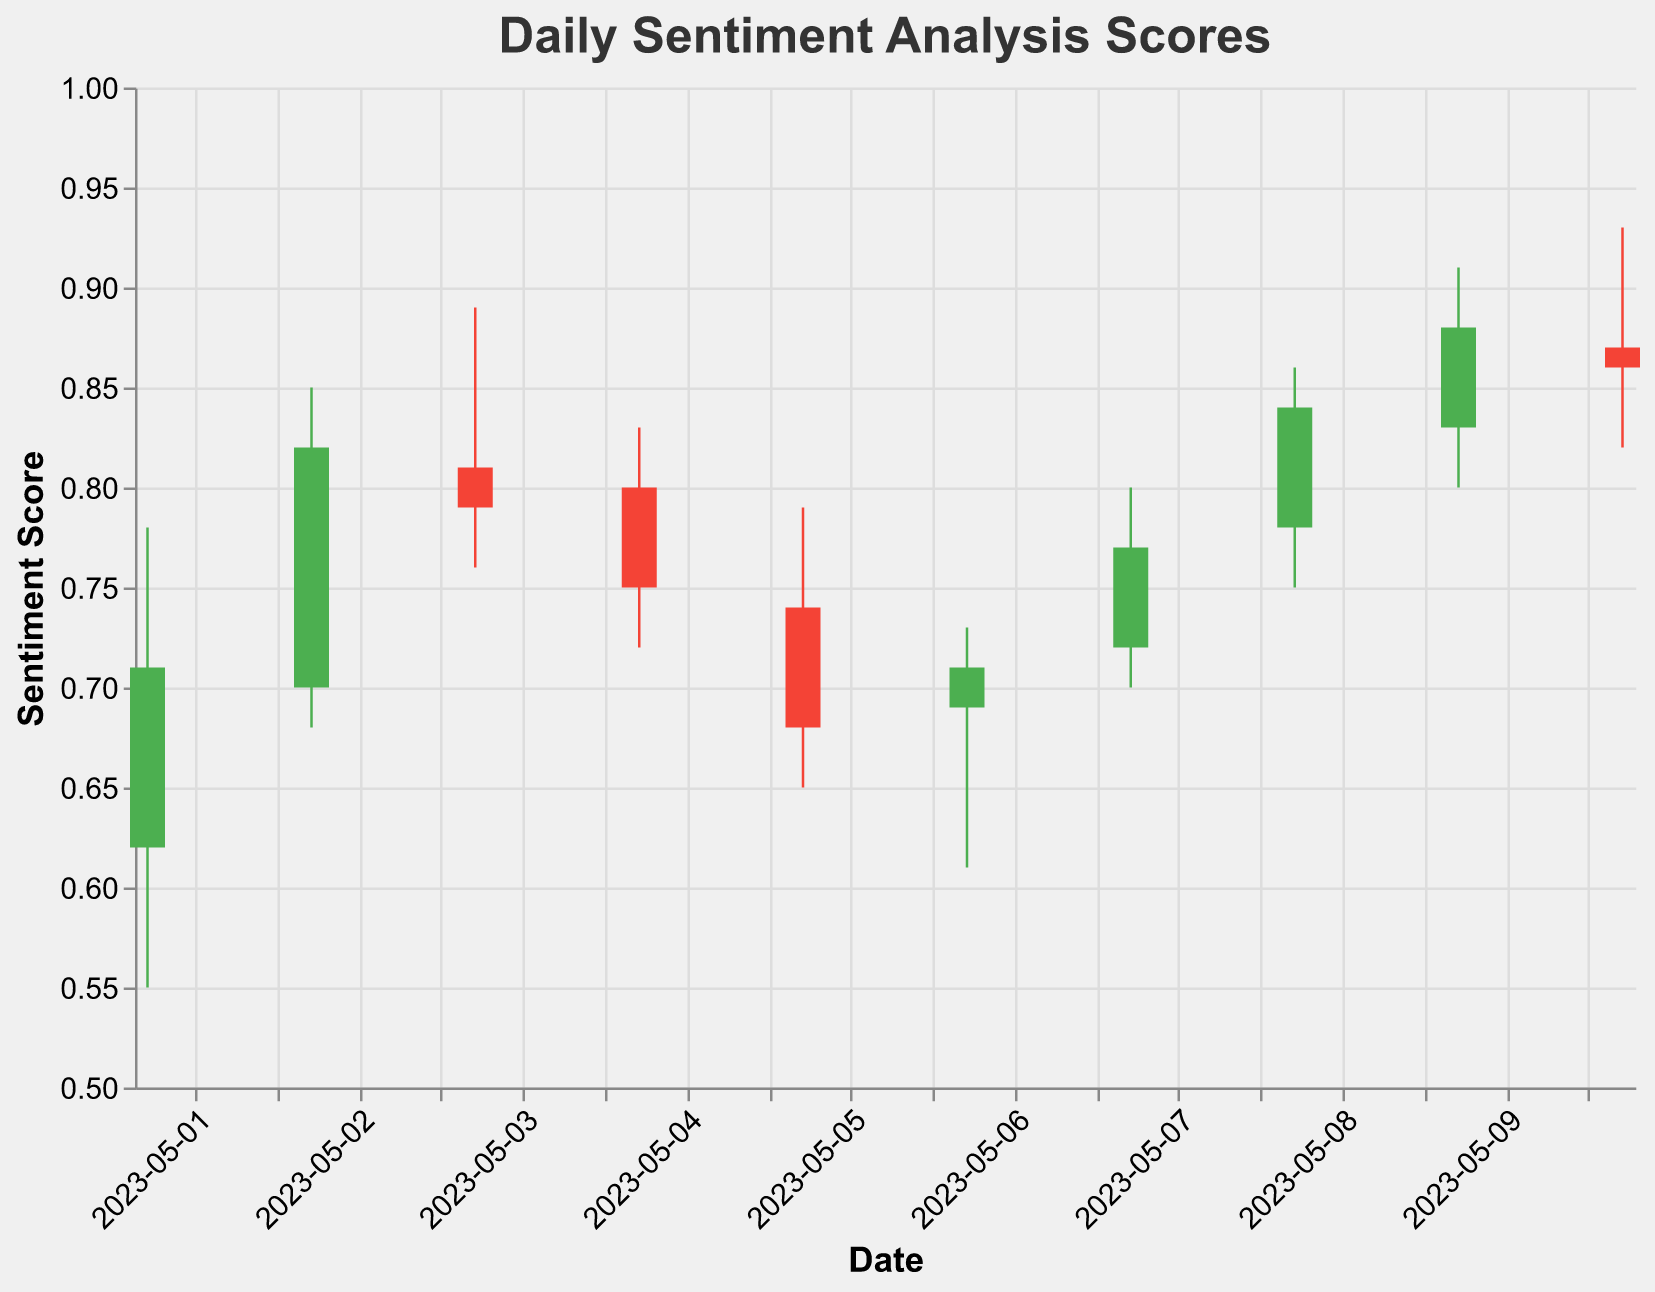What is the title of the chart? The title of the chart is typically displayed at the top of the figure. By reading it, we can determine the subject of the chart.
Answer: Daily Sentiment Analysis Scores What is the highest sentiment score recorded on May 10, 2023? Look at the row corresponding to May 10, 2023, and find the value under the "High" column.
Answer: 0.93 How many days show an increase in sentiment score from Open to Close? To determine this, we need to compare the "Open" and "Close" values for each day. A day shows an increase if the "Close" value is higher than the "Open" value.
Answer: 7 days On which date did the sentiment score have the lowest opening value across the entire dataset? Identify the lowest value in the "Open" column and find the corresponding date.
Answer: 2023-05-06 What are the sentiment scores (Open, High, Low, Close) on May 3, 2023? Locate the data for May 3, 2023, and list the values in the "Open," "High," "Low," and "Close" columns.
Answer: 0.81, 0.89, 0.76, 0.79 Which day shows the highest volatility in sentiment score (High - Low)? To find the day with the highest volatility, compute the difference (High - Low) for each date and identify the highest value.
Answer: 2023-05-10 How many days in the dataset have a negative sentiment trend (where the Close is lower than the Open)? Count the days where the sentiment scores close lower than they open.
Answer: 3 days What is the average closing sentiment score over the 10 days? Sum up all the closing sentiment scores and divide by the number of days (10). (0.71 + 0.82 + 0.79 + 0.75 + 0.68 + 0.71 + 0.77 + 0.84 + 0.88 + 0.86) / 10 = 7.81 / 10
Answer: 0.781 On which date did the sentiment score close at its lowest value? Look through the "Close" values to find the lowest one, then identify the corresponding date.
Answer: 2023-05-05 